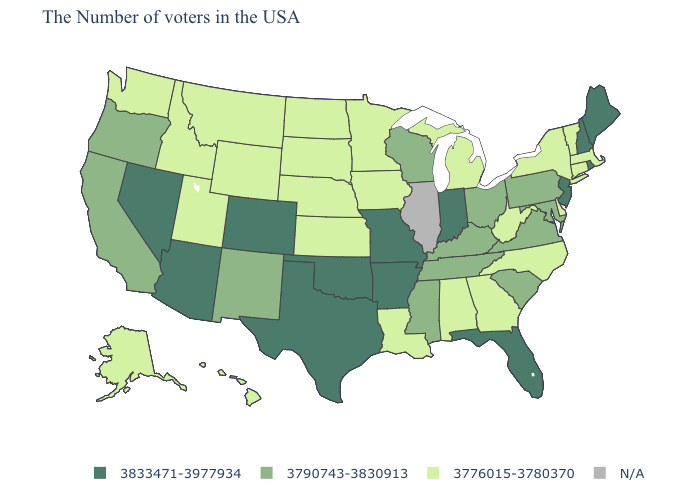Name the states that have a value in the range 3833471-3977934?
Keep it brief. Maine, Rhode Island, New Hampshire, New Jersey, Florida, Indiana, Missouri, Arkansas, Oklahoma, Texas, Colorado, Arizona, Nevada. Which states hav the highest value in the South?
Write a very short answer. Florida, Arkansas, Oklahoma, Texas. What is the value of Iowa?
Concise answer only. 3776015-3780370. Name the states that have a value in the range 3833471-3977934?
Concise answer only. Maine, Rhode Island, New Hampshire, New Jersey, Florida, Indiana, Missouri, Arkansas, Oklahoma, Texas, Colorado, Arizona, Nevada. What is the lowest value in states that border New Jersey?
Answer briefly. 3776015-3780370. Which states have the lowest value in the West?
Concise answer only. Wyoming, Utah, Montana, Idaho, Washington, Alaska, Hawaii. Does the map have missing data?
Quick response, please. Yes. Among the states that border New Jersey , which have the highest value?
Be succinct. Pennsylvania. Does Missouri have the highest value in the USA?
Short answer required. Yes. Which states hav the highest value in the West?
Short answer required. Colorado, Arizona, Nevada. What is the value of Oklahoma?
Concise answer only. 3833471-3977934. What is the value of Wisconsin?
Answer briefly. 3790743-3830913. Among the states that border Wyoming , which have the lowest value?
Answer briefly. Nebraska, South Dakota, Utah, Montana, Idaho. 